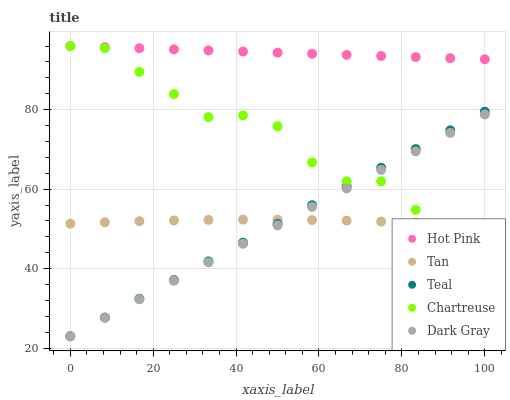Does Dark Gray have the minimum area under the curve?
Answer yes or no. Yes. Does Hot Pink have the maximum area under the curve?
Answer yes or no. Yes. Does Tan have the minimum area under the curve?
Answer yes or no. No. Does Tan have the maximum area under the curve?
Answer yes or no. No. Is Teal the smoothest?
Answer yes or no. Yes. Is Chartreuse the roughest?
Answer yes or no. Yes. Is Tan the smoothest?
Answer yes or no. No. Is Tan the roughest?
Answer yes or no. No. Does Dark Gray have the lowest value?
Answer yes or no. Yes. Does Tan have the lowest value?
Answer yes or no. No. Does Chartreuse have the highest value?
Answer yes or no. Yes. Does Tan have the highest value?
Answer yes or no. No. Is Tan less than Hot Pink?
Answer yes or no. Yes. Is Hot Pink greater than Tan?
Answer yes or no. Yes. Does Chartreuse intersect Hot Pink?
Answer yes or no. Yes. Is Chartreuse less than Hot Pink?
Answer yes or no. No. Is Chartreuse greater than Hot Pink?
Answer yes or no. No. Does Tan intersect Hot Pink?
Answer yes or no. No. 